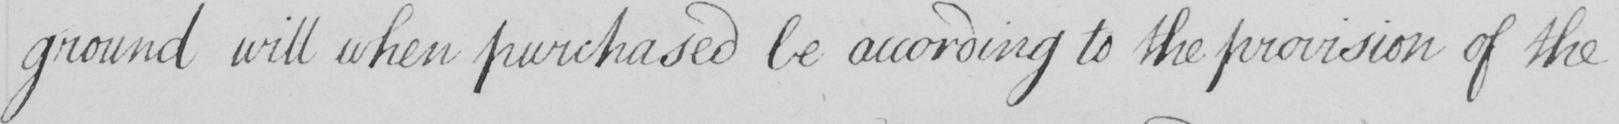What is written in this line of handwriting? ground will when purchased be according to the provision of the 